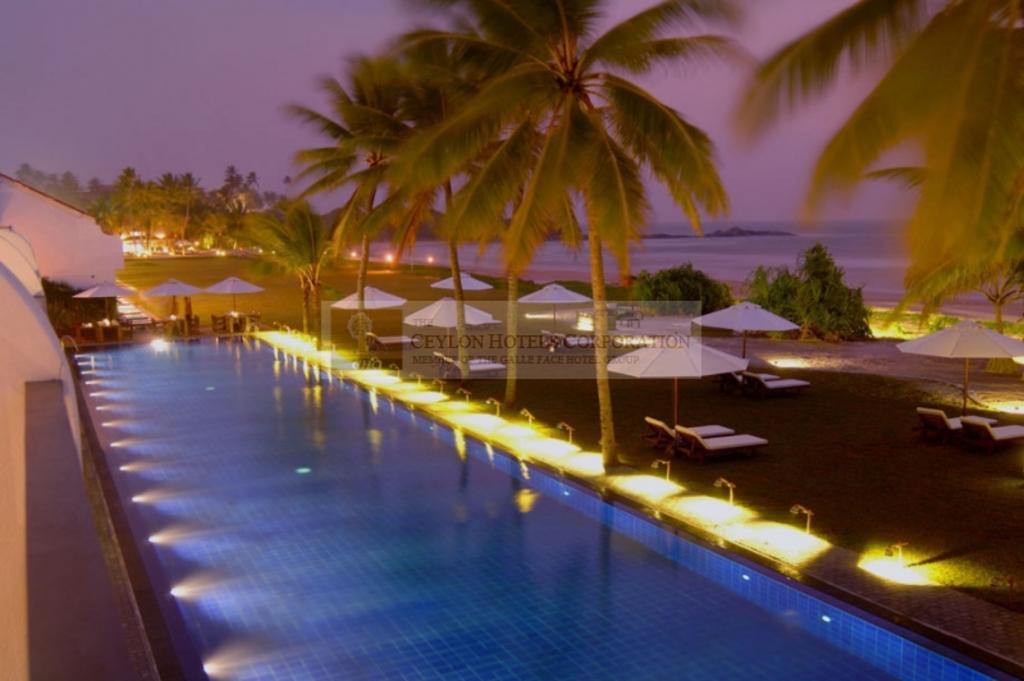How would you summarize this image in a sentence or two? in this image I can see a manual water pool with some lights and recreation area in a garden. I can see trees, some lights and a sea. At the top of the image I can see the sky. 